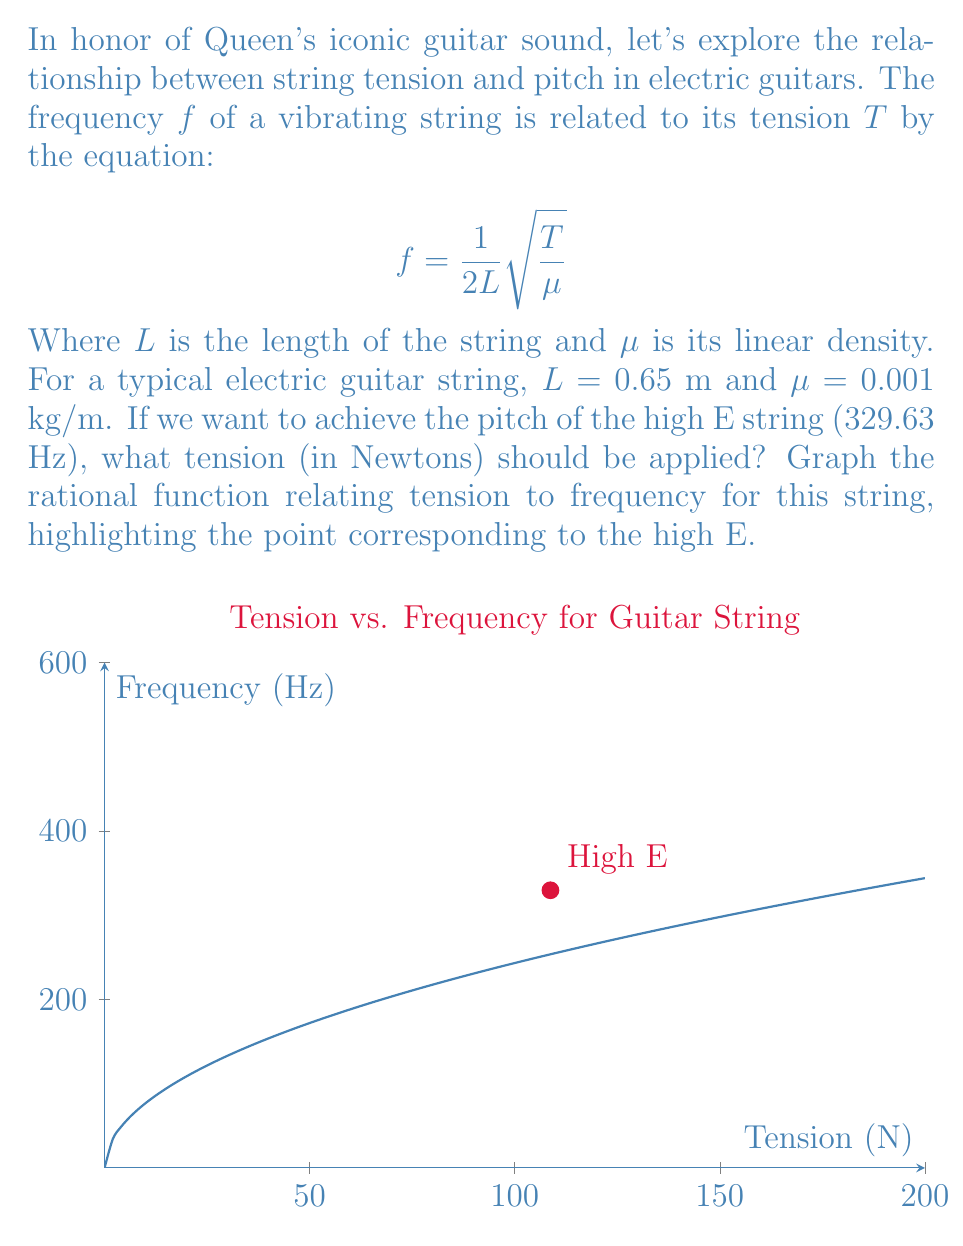Could you help me with this problem? Let's approach this step-by-step:

1) We start with the equation: $f = \frac{1}{2L}\sqrt{\frac{T}{\mu}}$

2) We're given:
   $f = 329.63$ Hz (high E string)
   $L = 0.65$ m
   $\mu = 0.001$ kg/m

3) Let's rearrange the equation to solve for $T$:
   
   $$f = \frac{1}{2L}\sqrt{\frac{T}{\mu}}$$
   $$f^2 = \frac{1}{4L^2}\frac{T}{\mu}$$
   $$T = 4L^2\mu f^2$$

4) Now, let's substitute our values:
   
   $$T = 4(0.65^2)(0.001)(329.63^2)$$

5) Calculating:
   
   $$T = 4(0.4225)(0.001)(108655.7369)$$
   $$T \approx 108.7 \text{ N}$$

6) To graph the function, we use the equation from step 3, but leave $f$ as our variable:
   
   $$T = 4L^2\mu f^2$$
   $$T = 4(0.65^2)(0.001)f^2$$
   $$T \approx 0.001098f^2$$

7) This is a quadratic function. When we graph $T$ against $f$, we get a parabola. The point $(108.7, 329.63)$ corresponds to our high E string.
Answer: $108.7 \text{ N}$ 